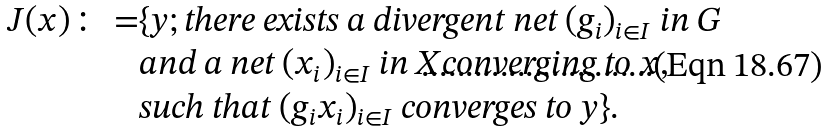<formula> <loc_0><loc_0><loc_500><loc_500>J ( x ) \colon = & \{ y ; \text {\em there exists a divergent net } ( g _ { i } ) _ { i \in I } \ \text {\em in } G \\ & \text {\em and a net } ( x _ { i } ) _ { i \in I } \ \text {\em in } X \text {\em converging to } x , \\ & \text {\em such that } ( g _ { i } x _ { i } ) _ { i \in I } \ \text {\em converges to } y \} .</formula> 